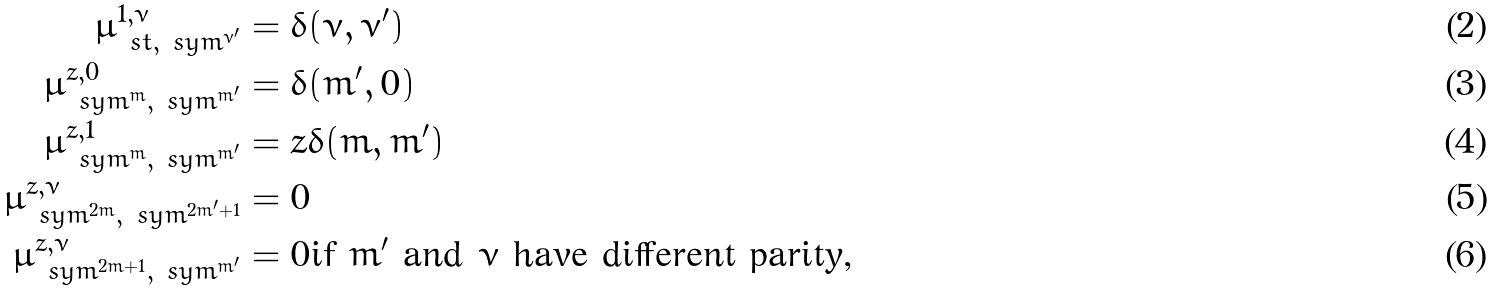Convert formula to latex. <formula><loc_0><loc_0><loc_500><loc_500>\mu ^ { 1 , \nu } _ { \ s t , \ s y m ^ { \nu ^ { \prime } } } & = \delta ( \nu , \nu ^ { \prime } ) \\ \mu _ { \ s y m ^ { m } , \ s y m ^ { m ^ { \prime } } } ^ { z , 0 } & = \delta ( m ^ { \prime } , 0 ) \\ \mu _ { \ s y m ^ { m } , \ s y m ^ { m ^ { \prime } } } ^ { z , 1 } & = z \delta ( m , m ^ { \prime } ) \\ \mu _ { \ s y m ^ { 2 m } , \ s y m ^ { 2 m ^ { \prime } + 1 } } ^ { z , \nu } & = 0 \\ \mu _ { \ s y m ^ { 2 m + 1 } , \ s y m ^ { m ^ { \prime } } } ^ { z , \nu } & = 0 \text {if $m^{\prime}$ and $\nu$ have different parity,}</formula> 